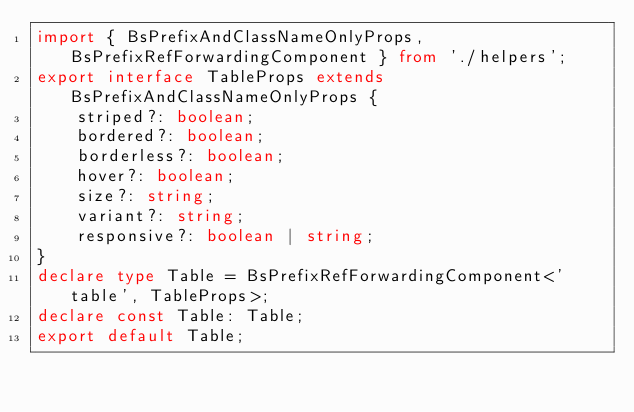<code> <loc_0><loc_0><loc_500><loc_500><_TypeScript_>import { BsPrefixAndClassNameOnlyProps, BsPrefixRefForwardingComponent } from './helpers';
export interface TableProps extends BsPrefixAndClassNameOnlyProps {
    striped?: boolean;
    bordered?: boolean;
    borderless?: boolean;
    hover?: boolean;
    size?: string;
    variant?: string;
    responsive?: boolean | string;
}
declare type Table = BsPrefixRefForwardingComponent<'table', TableProps>;
declare const Table: Table;
export default Table;
</code> 